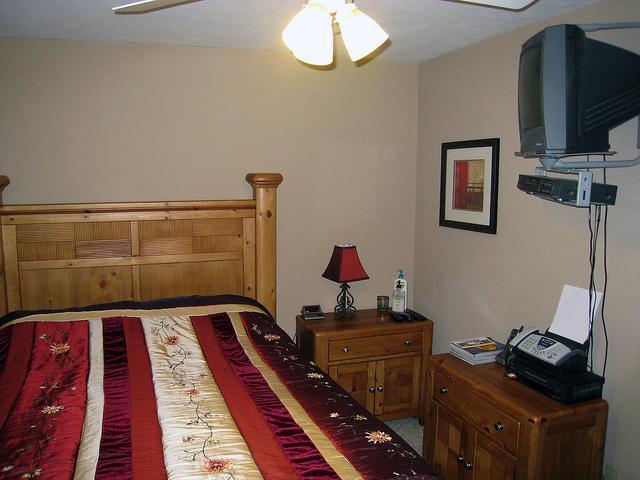What color is the main stripe on the right side of the queen sized bed?
Indicate the correct response by choosing from the four available options to answer the question.
Options: Yellow, white, pink, red. Red. 